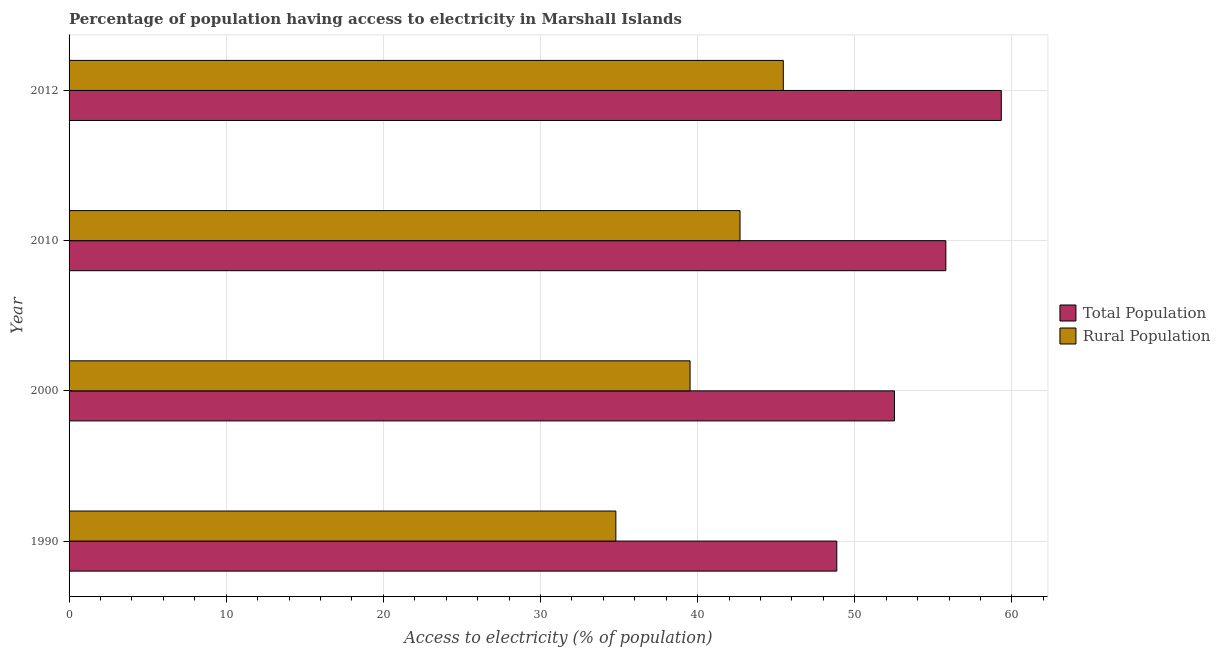Are the number of bars per tick equal to the number of legend labels?
Keep it short and to the point. Yes. How many bars are there on the 2nd tick from the top?
Ensure brevity in your answer.  2. How many bars are there on the 1st tick from the bottom?
Offer a very short reply. 2. In how many cases, is the number of bars for a given year not equal to the number of legend labels?
Your answer should be compact. 0. What is the percentage of rural population having access to electricity in 2000?
Ensure brevity in your answer.  39.52. Across all years, what is the maximum percentage of population having access to electricity?
Give a very brief answer. 59.33. Across all years, what is the minimum percentage of population having access to electricity?
Make the answer very short. 48.86. In which year was the percentage of rural population having access to electricity maximum?
Provide a short and direct response. 2012. In which year was the percentage of population having access to electricity minimum?
Your answer should be very brief. 1990. What is the total percentage of rural population having access to electricity in the graph?
Ensure brevity in your answer.  162.47. What is the difference between the percentage of rural population having access to electricity in 2000 and that in 2012?
Make the answer very short. -5.93. What is the difference between the percentage of population having access to electricity in 2000 and the percentage of rural population having access to electricity in 2012?
Your response must be concise. 7.08. What is the average percentage of rural population having access to electricity per year?
Give a very brief answer. 40.62. In how many years, is the percentage of rural population having access to electricity greater than 6 %?
Offer a terse response. 4. What is the ratio of the percentage of rural population having access to electricity in 2000 to that in 2010?
Provide a short and direct response. 0.93. Is the difference between the percentage of population having access to electricity in 1990 and 2010 greater than the difference between the percentage of rural population having access to electricity in 1990 and 2010?
Keep it short and to the point. Yes. What is the difference between the highest and the second highest percentage of rural population having access to electricity?
Provide a short and direct response. 2.75. What is the difference between the highest and the lowest percentage of rural population having access to electricity?
Provide a short and direct response. 10.66. Is the sum of the percentage of population having access to electricity in 1990 and 2010 greater than the maximum percentage of rural population having access to electricity across all years?
Your response must be concise. Yes. What does the 1st bar from the top in 2010 represents?
Give a very brief answer. Rural Population. What does the 2nd bar from the bottom in 2012 represents?
Ensure brevity in your answer.  Rural Population. How many bars are there?
Give a very brief answer. 8. Are all the bars in the graph horizontal?
Ensure brevity in your answer.  Yes. How many years are there in the graph?
Your answer should be very brief. 4. What is the difference between two consecutive major ticks on the X-axis?
Provide a succinct answer. 10. Are the values on the major ticks of X-axis written in scientific E-notation?
Ensure brevity in your answer.  No. Does the graph contain grids?
Your answer should be very brief. Yes. Where does the legend appear in the graph?
Provide a short and direct response. Center right. How many legend labels are there?
Your answer should be very brief. 2. How are the legend labels stacked?
Offer a terse response. Vertical. What is the title of the graph?
Make the answer very short. Percentage of population having access to electricity in Marshall Islands. What is the label or title of the X-axis?
Ensure brevity in your answer.  Access to electricity (% of population). What is the label or title of the Y-axis?
Ensure brevity in your answer.  Year. What is the Access to electricity (% of population) of Total Population in 1990?
Make the answer very short. 48.86. What is the Access to electricity (% of population) in Rural Population in 1990?
Ensure brevity in your answer.  34.8. What is the Access to electricity (% of population) in Total Population in 2000?
Offer a terse response. 52.53. What is the Access to electricity (% of population) in Rural Population in 2000?
Your answer should be compact. 39.52. What is the Access to electricity (% of population) in Total Population in 2010?
Make the answer very short. 55.8. What is the Access to electricity (% of population) of Rural Population in 2010?
Give a very brief answer. 42.7. What is the Access to electricity (% of population) in Total Population in 2012?
Provide a succinct answer. 59.33. What is the Access to electricity (% of population) in Rural Population in 2012?
Make the answer very short. 45.45. Across all years, what is the maximum Access to electricity (% of population) in Total Population?
Your answer should be compact. 59.33. Across all years, what is the maximum Access to electricity (% of population) of Rural Population?
Ensure brevity in your answer.  45.45. Across all years, what is the minimum Access to electricity (% of population) in Total Population?
Make the answer very short. 48.86. Across all years, what is the minimum Access to electricity (% of population) in Rural Population?
Make the answer very short. 34.8. What is the total Access to electricity (% of population) of Total Population in the graph?
Keep it short and to the point. 216.52. What is the total Access to electricity (% of population) of Rural Population in the graph?
Offer a very short reply. 162.47. What is the difference between the Access to electricity (% of population) in Total Population in 1990 and that in 2000?
Keep it short and to the point. -3.67. What is the difference between the Access to electricity (% of population) in Rural Population in 1990 and that in 2000?
Make the answer very short. -4.72. What is the difference between the Access to electricity (% of population) of Total Population in 1990 and that in 2010?
Provide a succinct answer. -6.94. What is the difference between the Access to electricity (% of population) of Rural Population in 1990 and that in 2010?
Provide a short and direct response. -7.9. What is the difference between the Access to electricity (% of population) of Total Population in 1990 and that in 2012?
Offer a very short reply. -10.47. What is the difference between the Access to electricity (% of population) of Rural Population in 1990 and that in 2012?
Keep it short and to the point. -10.66. What is the difference between the Access to electricity (% of population) of Total Population in 2000 and that in 2010?
Offer a terse response. -3.27. What is the difference between the Access to electricity (% of population) of Rural Population in 2000 and that in 2010?
Give a very brief answer. -3.18. What is the difference between the Access to electricity (% of population) of Total Population in 2000 and that in 2012?
Offer a terse response. -6.8. What is the difference between the Access to electricity (% of population) in Rural Population in 2000 and that in 2012?
Offer a terse response. -5.93. What is the difference between the Access to electricity (% of population) of Total Population in 2010 and that in 2012?
Your answer should be compact. -3.53. What is the difference between the Access to electricity (% of population) in Rural Population in 2010 and that in 2012?
Offer a terse response. -2.75. What is the difference between the Access to electricity (% of population) in Total Population in 1990 and the Access to electricity (% of population) in Rural Population in 2000?
Give a very brief answer. 9.34. What is the difference between the Access to electricity (% of population) in Total Population in 1990 and the Access to electricity (% of population) in Rural Population in 2010?
Your answer should be compact. 6.16. What is the difference between the Access to electricity (% of population) of Total Population in 1990 and the Access to electricity (% of population) of Rural Population in 2012?
Give a very brief answer. 3.4. What is the difference between the Access to electricity (% of population) in Total Population in 2000 and the Access to electricity (% of population) in Rural Population in 2010?
Offer a terse response. 9.83. What is the difference between the Access to electricity (% of population) of Total Population in 2000 and the Access to electricity (% of population) of Rural Population in 2012?
Provide a succinct answer. 7.08. What is the difference between the Access to electricity (% of population) in Total Population in 2010 and the Access to electricity (% of population) in Rural Population in 2012?
Give a very brief answer. 10.35. What is the average Access to electricity (% of population) of Total Population per year?
Provide a succinct answer. 54.13. What is the average Access to electricity (% of population) in Rural Population per year?
Make the answer very short. 40.62. In the year 1990, what is the difference between the Access to electricity (% of population) in Total Population and Access to electricity (% of population) in Rural Population?
Ensure brevity in your answer.  14.06. In the year 2000, what is the difference between the Access to electricity (% of population) of Total Population and Access to electricity (% of population) of Rural Population?
Your answer should be very brief. 13.01. In the year 2012, what is the difference between the Access to electricity (% of population) in Total Population and Access to electricity (% of population) in Rural Population?
Offer a very short reply. 13.87. What is the ratio of the Access to electricity (% of population) of Total Population in 1990 to that in 2000?
Keep it short and to the point. 0.93. What is the ratio of the Access to electricity (% of population) in Rural Population in 1990 to that in 2000?
Ensure brevity in your answer.  0.88. What is the ratio of the Access to electricity (% of population) of Total Population in 1990 to that in 2010?
Provide a short and direct response. 0.88. What is the ratio of the Access to electricity (% of population) of Rural Population in 1990 to that in 2010?
Your answer should be compact. 0.81. What is the ratio of the Access to electricity (% of population) of Total Population in 1990 to that in 2012?
Provide a succinct answer. 0.82. What is the ratio of the Access to electricity (% of population) of Rural Population in 1990 to that in 2012?
Keep it short and to the point. 0.77. What is the ratio of the Access to electricity (% of population) in Total Population in 2000 to that in 2010?
Your answer should be very brief. 0.94. What is the ratio of the Access to electricity (% of population) of Rural Population in 2000 to that in 2010?
Ensure brevity in your answer.  0.93. What is the ratio of the Access to electricity (% of population) in Total Population in 2000 to that in 2012?
Your response must be concise. 0.89. What is the ratio of the Access to electricity (% of population) in Rural Population in 2000 to that in 2012?
Offer a terse response. 0.87. What is the ratio of the Access to electricity (% of population) of Total Population in 2010 to that in 2012?
Your answer should be compact. 0.94. What is the ratio of the Access to electricity (% of population) of Rural Population in 2010 to that in 2012?
Offer a very short reply. 0.94. What is the difference between the highest and the second highest Access to electricity (% of population) of Total Population?
Offer a terse response. 3.53. What is the difference between the highest and the second highest Access to electricity (% of population) in Rural Population?
Provide a short and direct response. 2.75. What is the difference between the highest and the lowest Access to electricity (% of population) of Total Population?
Make the answer very short. 10.47. What is the difference between the highest and the lowest Access to electricity (% of population) in Rural Population?
Provide a short and direct response. 10.66. 